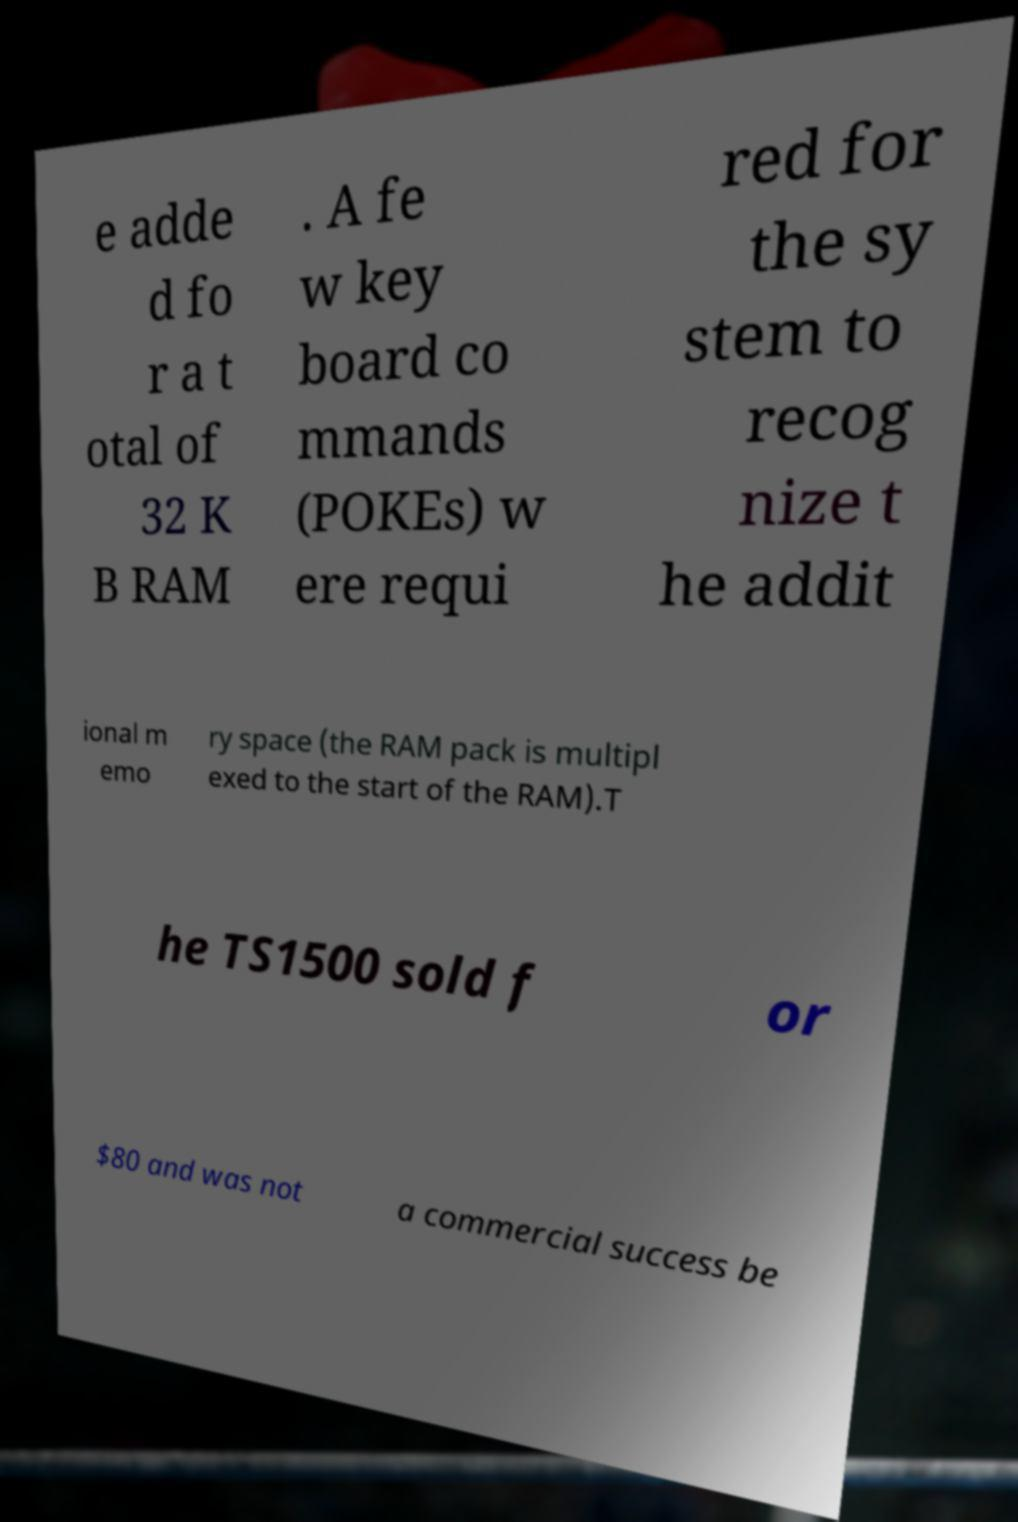I need the written content from this picture converted into text. Can you do that? e adde d fo r a t otal of 32 K B RAM . A fe w key board co mmands (POKEs) w ere requi red for the sy stem to recog nize t he addit ional m emo ry space (the RAM pack is multipl exed to the start of the RAM).T he TS1500 sold f or $80 and was not a commercial success be 